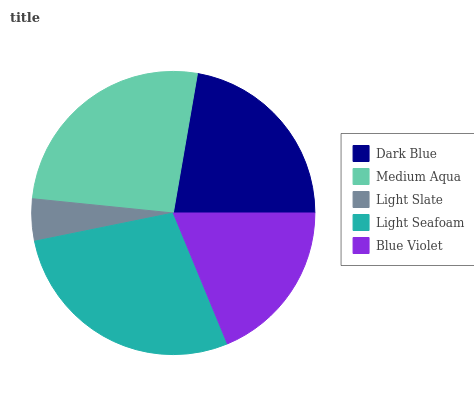Is Light Slate the minimum?
Answer yes or no. Yes. Is Light Seafoam the maximum?
Answer yes or no. Yes. Is Medium Aqua the minimum?
Answer yes or no. No. Is Medium Aqua the maximum?
Answer yes or no. No. Is Medium Aqua greater than Dark Blue?
Answer yes or no. Yes. Is Dark Blue less than Medium Aqua?
Answer yes or no. Yes. Is Dark Blue greater than Medium Aqua?
Answer yes or no. No. Is Medium Aqua less than Dark Blue?
Answer yes or no. No. Is Dark Blue the high median?
Answer yes or no. Yes. Is Dark Blue the low median?
Answer yes or no. Yes. Is Light Seafoam the high median?
Answer yes or no. No. Is Blue Violet the low median?
Answer yes or no. No. 